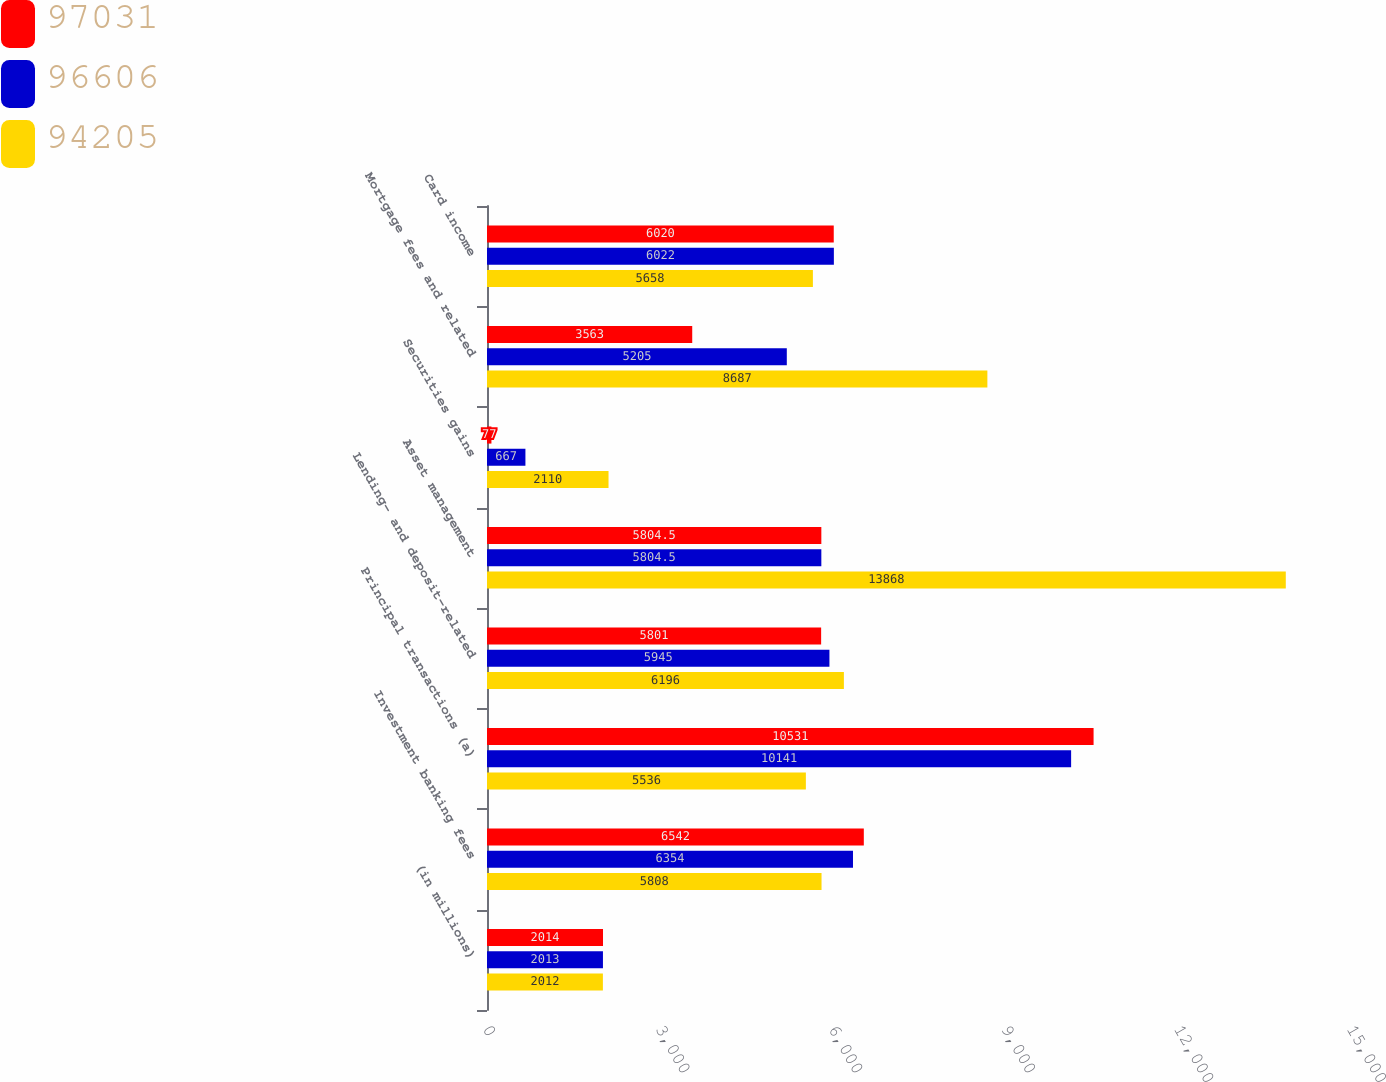Convert chart. <chart><loc_0><loc_0><loc_500><loc_500><stacked_bar_chart><ecel><fcel>(in millions)<fcel>Investment banking fees<fcel>Principal transactions (a)<fcel>Lending- and deposit-related<fcel>Asset management<fcel>Securities gains<fcel>Mortgage fees and related<fcel>Card income<nl><fcel>97031<fcel>2014<fcel>6542<fcel>10531<fcel>5801<fcel>5804.5<fcel>77<fcel>3563<fcel>6020<nl><fcel>96606<fcel>2013<fcel>6354<fcel>10141<fcel>5945<fcel>5804.5<fcel>667<fcel>5205<fcel>6022<nl><fcel>94205<fcel>2012<fcel>5808<fcel>5536<fcel>6196<fcel>13868<fcel>2110<fcel>8687<fcel>5658<nl></chart> 